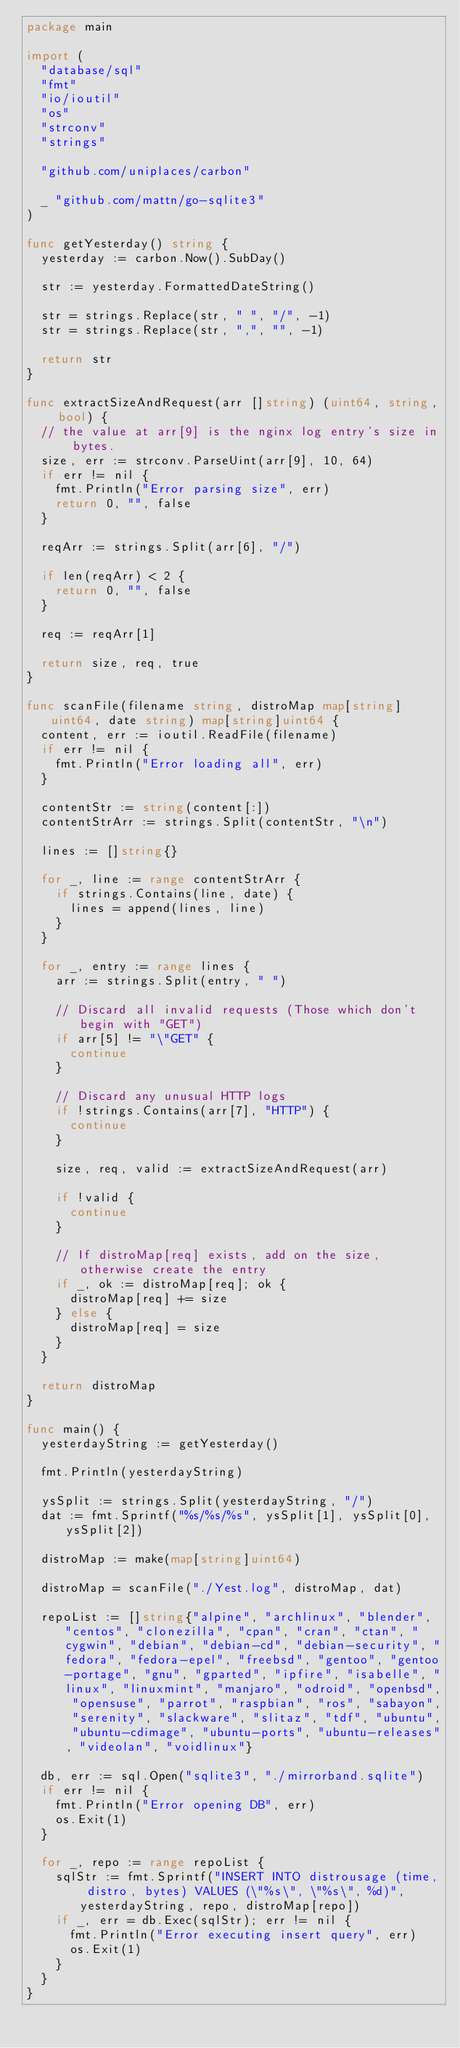Convert code to text. <code><loc_0><loc_0><loc_500><loc_500><_Go_>package main

import (
	"database/sql"
	"fmt"
	"io/ioutil"
	"os"
	"strconv"
	"strings"

	"github.com/uniplaces/carbon"

	_ "github.com/mattn/go-sqlite3"
)

func getYesterday() string {
	yesterday := carbon.Now().SubDay()

	str := yesterday.FormattedDateString()

	str = strings.Replace(str, " ", "/", -1)
	str = strings.Replace(str, ",", "", -1)

	return str
}

func extractSizeAndRequest(arr []string) (uint64, string, bool) {
	// the value at arr[9] is the nginx log entry's size in bytes.
	size, err := strconv.ParseUint(arr[9], 10, 64)
	if err != nil {
		fmt.Println("Error parsing size", err)
		return 0, "", false
	}

	reqArr := strings.Split(arr[6], "/")

	if len(reqArr) < 2 {
		return 0, "", false
	}

	req := reqArr[1]

	return size, req, true
}

func scanFile(filename string, distroMap map[string]uint64, date string) map[string]uint64 {
	content, err := ioutil.ReadFile(filename)
	if err != nil {
		fmt.Println("Error loading all", err)
	}

	contentStr := string(content[:])
	contentStrArr := strings.Split(contentStr, "\n")

	lines := []string{}

	for _, line := range contentStrArr {
		if strings.Contains(line, date) {
			lines = append(lines, line)
		}
	}

	for _, entry := range lines {
		arr := strings.Split(entry, " ")

		// Discard all invalid requests (Those which don't begin with "GET")
		if arr[5] != "\"GET" {
			continue
		}

		// Discard any unusual HTTP logs
		if !strings.Contains(arr[7], "HTTP") {
			continue
		}

		size, req, valid := extractSizeAndRequest(arr)

		if !valid {
			continue
		}

		// If distroMap[req] exists, add on the size, otherwise create the entry
		if _, ok := distroMap[req]; ok {
			distroMap[req] += size
		} else {
			distroMap[req] = size
		}
	}

	return distroMap
}

func main() {
	yesterdayString := getYesterday()

	fmt.Println(yesterdayString)

	ysSplit := strings.Split(yesterdayString, "/")
	dat := fmt.Sprintf("%s/%s/%s", ysSplit[1], ysSplit[0], ysSplit[2])

	distroMap := make(map[string]uint64)

	distroMap = scanFile("./Yest.log", distroMap, dat)

	repoList := []string{"alpine", "archlinux", "blender", "centos", "clonezilla", "cpan", "cran", "ctan", "cygwin", "debian", "debian-cd", "debian-security", "fedora", "fedora-epel", "freebsd", "gentoo", "gentoo-portage", "gnu", "gparted", "ipfire", "isabelle", "linux", "linuxmint", "manjaro", "odroid", "openbsd", "opensuse", "parrot", "raspbian", "ros", "sabayon", "serenity", "slackware", "slitaz", "tdf", "ubuntu", "ubuntu-cdimage", "ubuntu-ports", "ubuntu-releases", "videolan", "voidlinux"}

	db, err := sql.Open("sqlite3", "./mirrorband.sqlite")
	if err != nil {
		fmt.Println("Error opening DB", err)
		os.Exit(1)
	}

	for _, repo := range repoList {
		sqlStr := fmt.Sprintf("INSERT INTO distrousage (time, distro, bytes) VALUES (\"%s\", \"%s\", %d)", yesterdayString, repo, distroMap[repo])
		if _, err = db.Exec(sqlStr); err != nil {
			fmt.Println("Error executing insert query", err)
			os.Exit(1)
		}
	}
}
</code> 